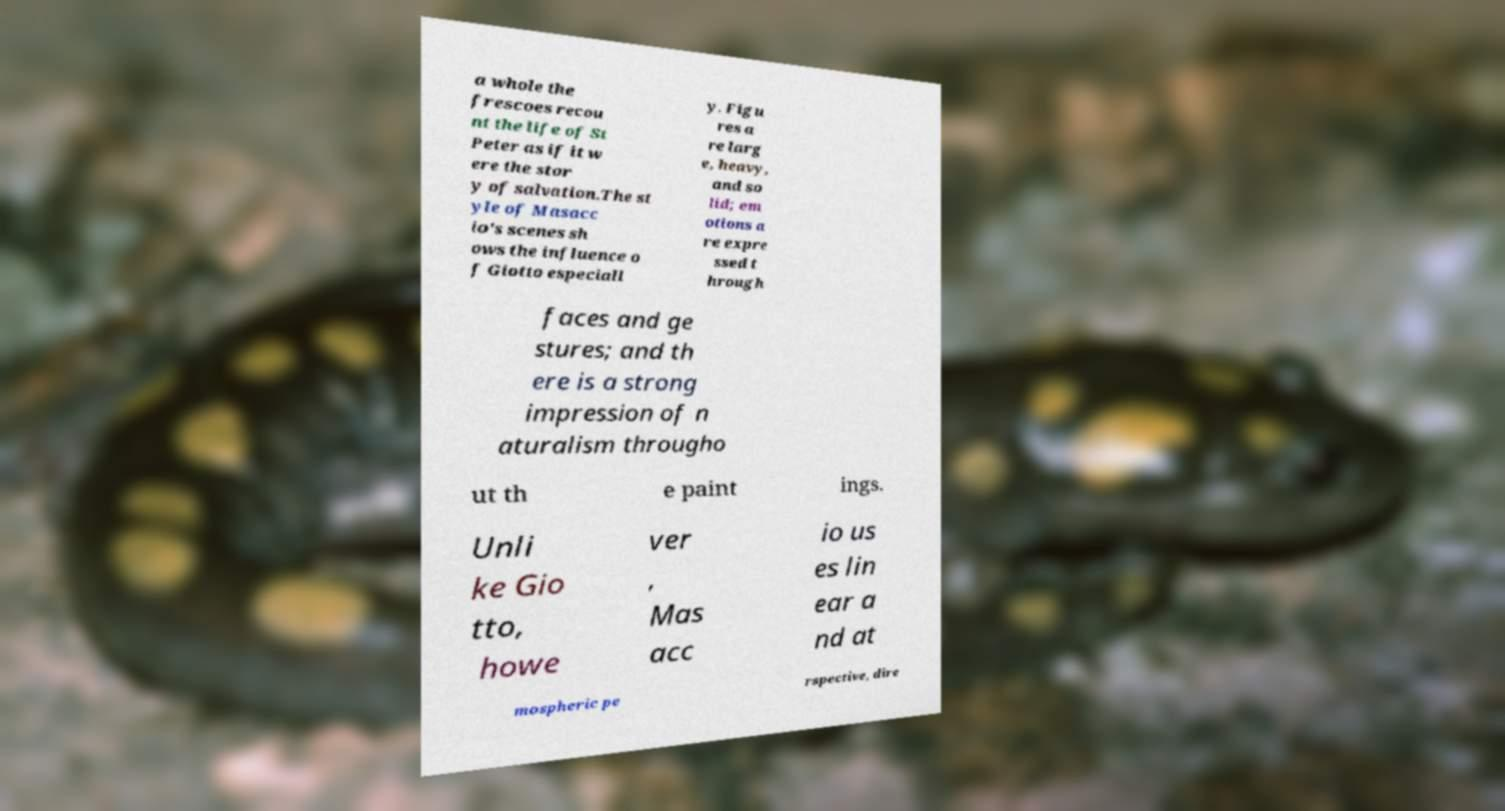I need the written content from this picture converted into text. Can you do that? a whole the frescoes recou nt the life of St Peter as if it w ere the stor y of salvation.The st yle of Masacc io's scenes sh ows the influence o f Giotto especiall y. Figu res a re larg e, heavy, and so lid; em otions a re expre ssed t hrough faces and ge stures; and th ere is a strong impression of n aturalism througho ut th e paint ings. Unli ke Gio tto, howe ver , Mas acc io us es lin ear a nd at mospheric pe rspective, dire 